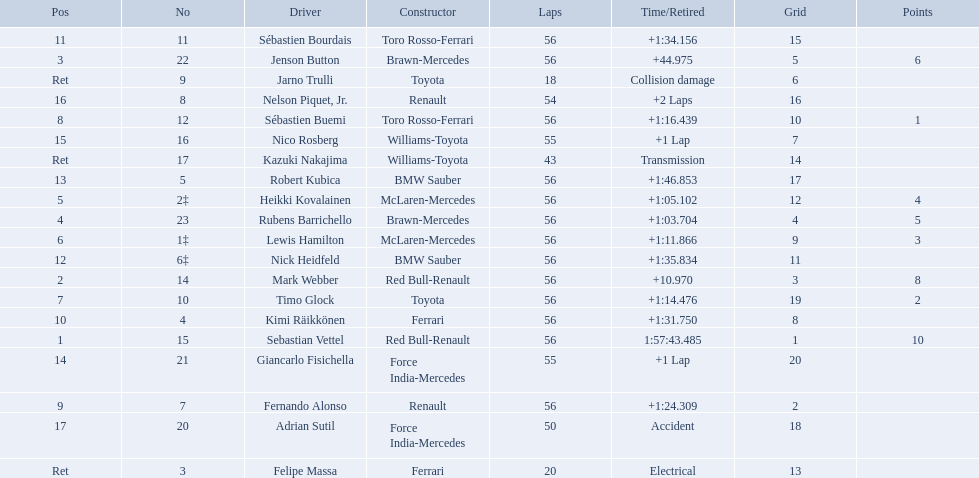Which drivers took part in the 2009 chinese grand prix? Sebastian Vettel, Mark Webber, Jenson Button, Rubens Barrichello, Heikki Kovalainen, Lewis Hamilton, Timo Glock, Sébastien Buemi, Fernando Alonso, Kimi Räikkönen, Sébastien Bourdais, Nick Heidfeld, Robert Kubica, Giancarlo Fisichella, Nico Rosberg, Nelson Piquet, Jr., Adrian Sutil, Kazuki Nakajima, Felipe Massa, Jarno Trulli. Parse the full table. {'header': ['Pos', 'No', 'Driver', 'Constructor', 'Laps', 'Time/Retired', 'Grid', 'Points'], 'rows': [['11', '11', 'Sébastien Bourdais', 'Toro Rosso-Ferrari', '56', '+1:34.156', '15', ''], ['3', '22', 'Jenson Button', 'Brawn-Mercedes', '56', '+44.975', '5', '6'], ['Ret', '9', 'Jarno Trulli', 'Toyota', '18', 'Collision damage', '6', ''], ['16', '8', 'Nelson Piquet, Jr.', 'Renault', '54', '+2 Laps', '16', ''], ['8', '12', 'Sébastien Buemi', 'Toro Rosso-Ferrari', '56', '+1:16.439', '10', '1'], ['15', '16', 'Nico Rosberg', 'Williams-Toyota', '55', '+1 Lap', '7', ''], ['Ret', '17', 'Kazuki Nakajima', 'Williams-Toyota', '43', 'Transmission', '14', ''], ['13', '5', 'Robert Kubica', 'BMW Sauber', '56', '+1:46.853', '17', ''], ['5', '2‡', 'Heikki Kovalainen', 'McLaren-Mercedes', '56', '+1:05.102', '12', '4'], ['4', '23', 'Rubens Barrichello', 'Brawn-Mercedes', '56', '+1:03.704', '4', '5'], ['6', '1‡', 'Lewis Hamilton', 'McLaren-Mercedes', '56', '+1:11.866', '9', '3'], ['12', '6‡', 'Nick Heidfeld', 'BMW Sauber', '56', '+1:35.834', '11', ''], ['2', '14', 'Mark Webber', 'Red Bull-Renault', '56', '+10.970', '3', '8'], ['7', '10', 'Timo Glock', 'Toyota', '56', '+1:14.476', '19', '2'], ['10', '4', 'Kimi Räikkönen', 'Ferrari', '56', '+1:31.750', '8', ''], ['1', '15', 'Sebastian Vettel', 'Red Bull-Renault', '56', '1:57:43.485', '1', '10'], ['14', '21', 'Giancarlo Fisichella', 'Force India-Mercedes', '55', '+1 Lap', '20', ''], ['9', '7', 'Fernando Alonso', 'Renault', '56', '+1:24.309', '2', ''], ['17', '20', 'Adrian Sutil', 'Force India-Mercedes', '50', 'Accident', '18', ''], ['Ret', '3', 'Felipe Massa', 'Ferrari', '20', 'Electrical', '13', '']]} Of these, who completed all 56 laps? Sebastian Vettel, Mark Webber, Jenson Button, Rubens Barrichello, Heikki Kovalainen, Lewis Hamilton, Timo Glock, Sébastien Buemi, Fernando Alonso, Kimi Räikkönen, Sébastien Bourdais, Nick Heidfeld, Robert Kubica. Of these, which did ferrari not participate as a constructor? Sebastian Vettel, Mark Webber, Jenson Button, Rubens Barrichello, Heikki Kovalainen, Lewis Hamilton, Timo Glock, Fernando Alonso, Kimi Räikkönen, Nick Heidfeld, Robert Kubica. Of the remaining, which is in pos 1? Sebastian Vettel. 